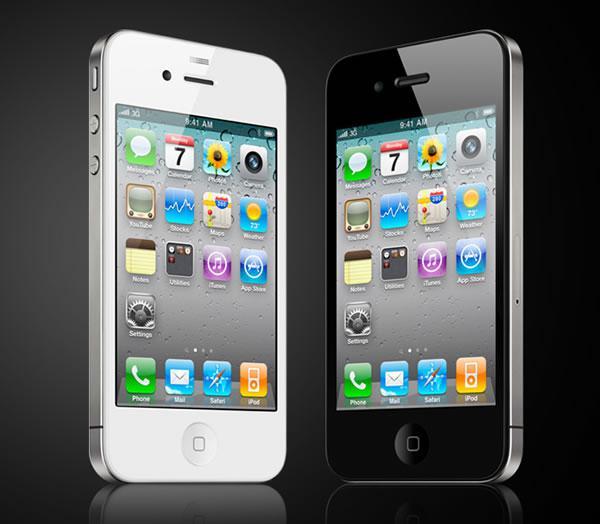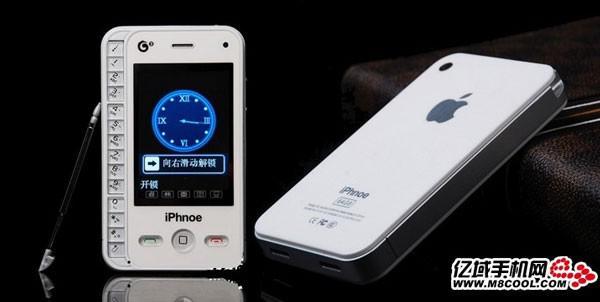The first image is the image on the left, the second image is the image on the right. Evaluate the accuracy of this statement regarding the images: "The right image features a black phone held by a hand with the thumb on the right, and the left image contains at least one phone but no hand.". Is it true? Answer yes or no. No. The first image is the image on the left, the second image is the image on the right. Analyze the images presented: Is the assertion "A phone sits alone in the image on the left, while the phone in the image on the right is held." valid? Answer yes or no. No. 